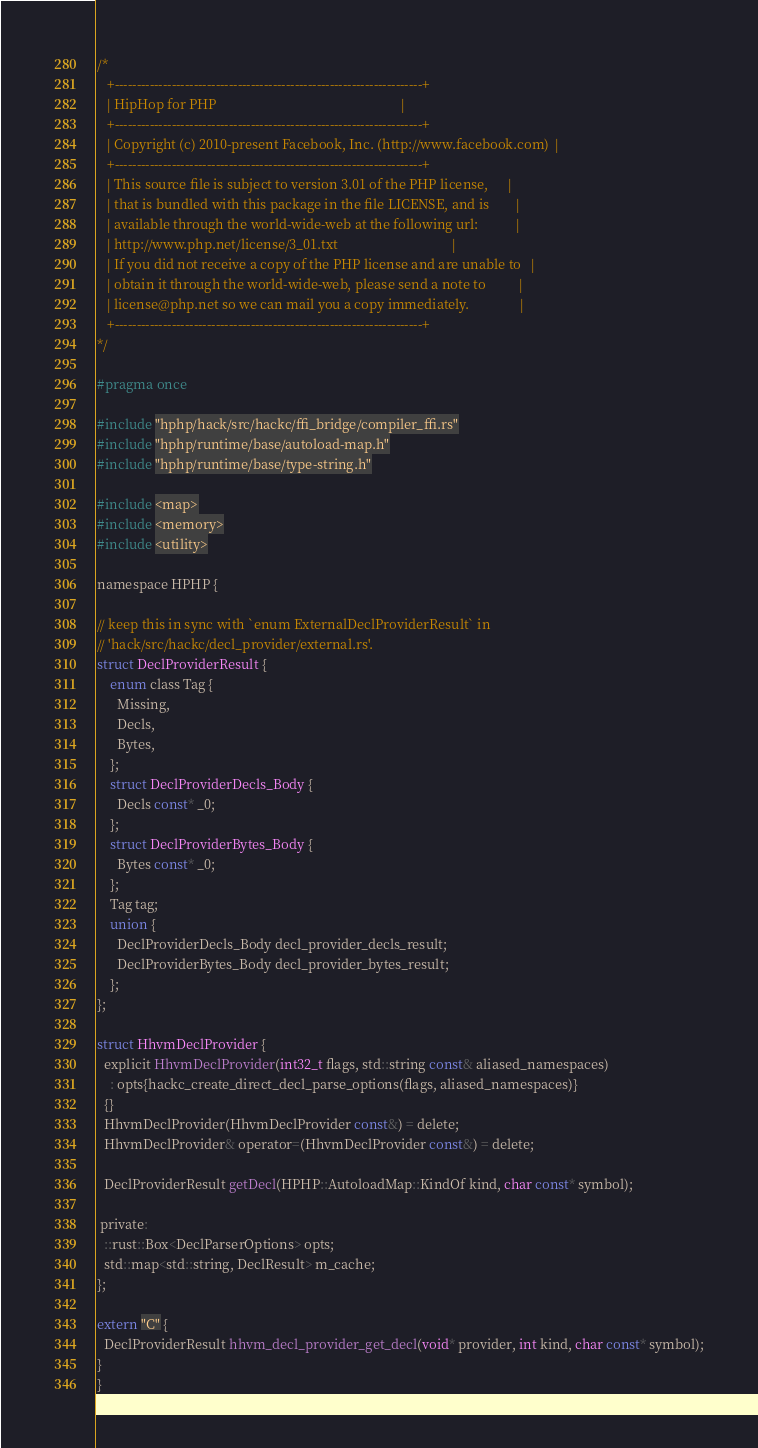Convert code to text. <code><loc_0><loc_0><loc_500><loc_500><_C_>/*
   +----------------------------------------------------------------------+
   | HipHop for PHP                                                       |
   +----------------------------------------------------------------------+
   | Copyright (c) 2010-present Facebook, Inc. (http://www.facebook.com)  |
   +----------------------------------------------------------------------+
   | This source file is subject to version 3.01 of the PHP license,      |
   | that is bundled with this package in the file LICENSE, and is        |
   | available through the world-wide-web at the following url:           |
   | http://www.php.net/license/3_01.txt                                  |
   | If you did not receive a copy of the PHP license and are unable to   |
   | obtain it through the world-wide-web, please send a note to          |
   | license@php.net so we can mail you a copy immediately.               |
   +----------------------------------------------------------------------+
*/

#pragma once

#include "hphp/hack/src/hackc/ffi_bridge/compiler_ffi.rs"
#include "hphp/runtime/base/autoload-map.h"
#include "hphp/runtime/base/type-string.h"

#include <map>
#include <memory>
#include <utility>

namespace HPHP {

// keep this in sync with `enum ExternalDeclProviderResult` in
// 'hack/src/hackc/decl_provider/external.rs'.
struct DeclProviderResult {
    enum class Tag {
      Missing,
      Decls,
      Bytes,
    };
    struct DeclProviderDecls_Body {
      Decls const* _0;
    };
    struct DeclProviderBytes_Body {
      Bytes const* _0;
    };
    Tag tag;
    union {
      DeclProviderDecls_Body decl_provider_decls_result;
      DeclProviderBytes_Body decl_provider_bytes_result;
    };
};

struct HhvmDeclProvider {
  explicit HhvmDeclProvider(int32_t flags, std::string const& aliased_namespaces)
    : opts{hackc_create_direct_decl_parse_options(flags, aliased_namespaces)}
  {}
  HhvmDeclProvider(HhvmDeclProvider const&) = delete;
  HhvmDeclProvider& operator=(HhvmDeclProvider const&) = delete;

  DeclProviderResult getDecl(HPHP::AutoloadMap::KindOf kind, char const* symbol);

 private:
  ::rust::Box<DeclParserOptions> opts;
  std::map<std::string, DeclResult> m_cache;
};

extern "C" {
  DeclProviderResult hhvm_decl_provider_get_decl(void* provider, int kind, char const* symbol);
}
}
</code> 